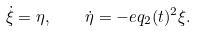Convert formula to latex. <formula><loc_0><loc_0><loc_500><loc_500>\dot { \xi } = \eta , \quad \dot { \eta } = - e q _ { 2 } ( t ) ^ { 2 } \xi .</formula> 